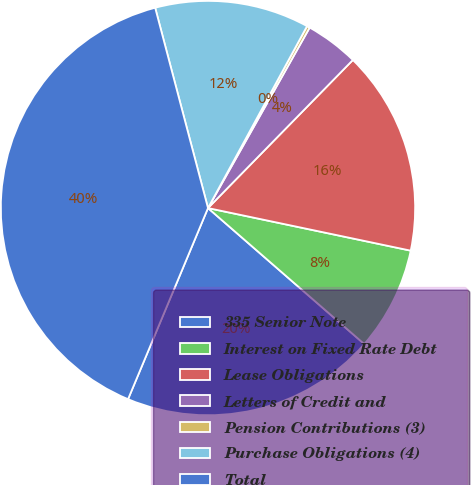<chart> <loc_0><loc_0><loc_500><loc_500><pie_chart><fcel>335 Senior Note<fcel>Interest on Fixed Rate Debt<fcel>Lease Obligations<fcel>Letters of Credit and<fcel>Pension Contributions (3)<fcel>Purchase Obligations (4)<fcel>Total<nl><fcel>19.91%<fcel>8.1%<fcel>15.97%<fcel>4.16%<fcel>0.23%<fcel>12.04%<fcel>39.59%<nl></chart> 